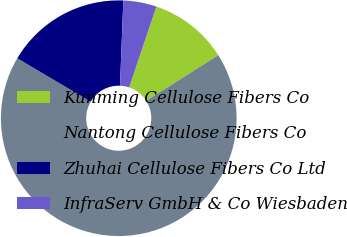Convert chart. <chart><loc_0><loc_0><loc_500><loc_500><pie_chart><fcel>Kunming Cellulose Fibers Co<fcel>Nantong Cellulose Fibers Co<fcel>Zhuhai Cellulose Fibers Co Ltd<fcel>InfraServ GmbH & Co Wiesbaden<nl><fcel>10.84%<fcel>67.48%<fcel>17.13%<fcel>4.55%<nl></chart> 